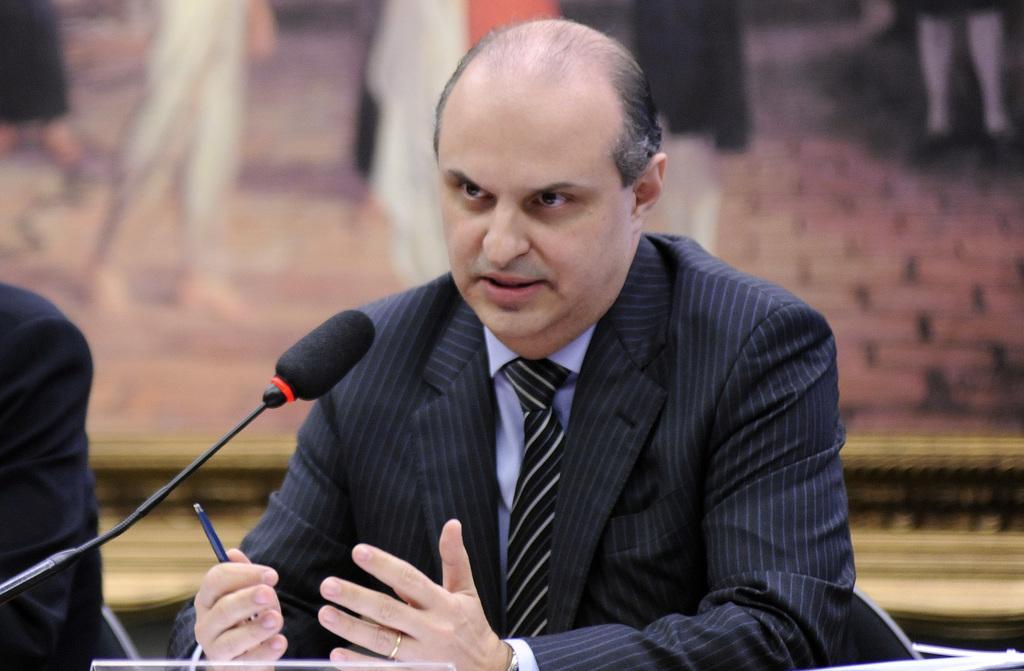Please provide a concise description of this image. In this image I can see a person wearing black colored blazer and tie is sitting and holding a pen. I can see a microphone in front of him and the blurry background. 